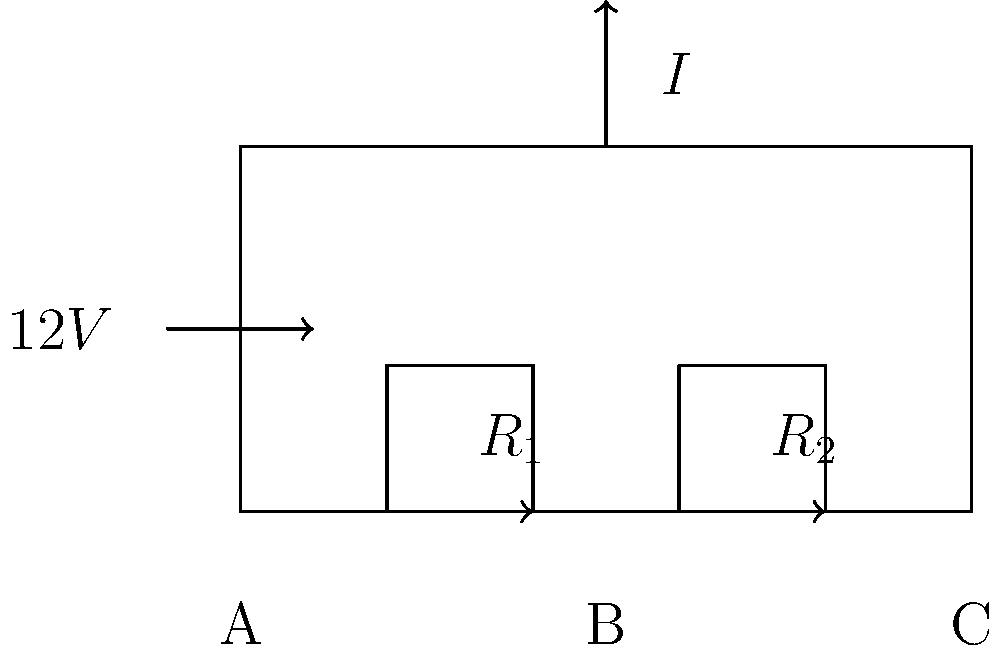In the circuit diagram above, a 12V voltage source is connected to two resistors in series, $R_1 = 20\Omega$ and $R_2 = 40\Omega$. Calculate the voltage drop across resistor $R_2$ (between points B and C). Express your answer in volts. To solve this problem, we'll follow these steps:

1) First, calculate the total resistance of the circuit:
   $R_{total} = R_1 + R_2 = 20\Omega + 40\Omega = 60\Omega$

2) Use Ohm's law to find the current in the circuit:
   $I = \frac{V}{R_{total}} = \frac{12V}{60\Omega} = 0.2A$

3) The voltage drop across $R_2$ can be calculated using Ohm's law again:
   $V_{R2} = I \times R_2 = 0.2A \times 40\Omega = 8V$

Alternatively, we could have used the voltage divider formula:
$V_{R2} = V_{total} \times \frac{R_2}{R_1 + R_2} = 12V \times \frac{40\Omega}{60\Omega} = 8V$

This problem demonstrates how voltage is distributed in a series circuit, which is proportional to the resistance values. As a handball player, you might relate this to how the effort in a game is distributed among team members based on their positions and roles.
Answer: 8V 